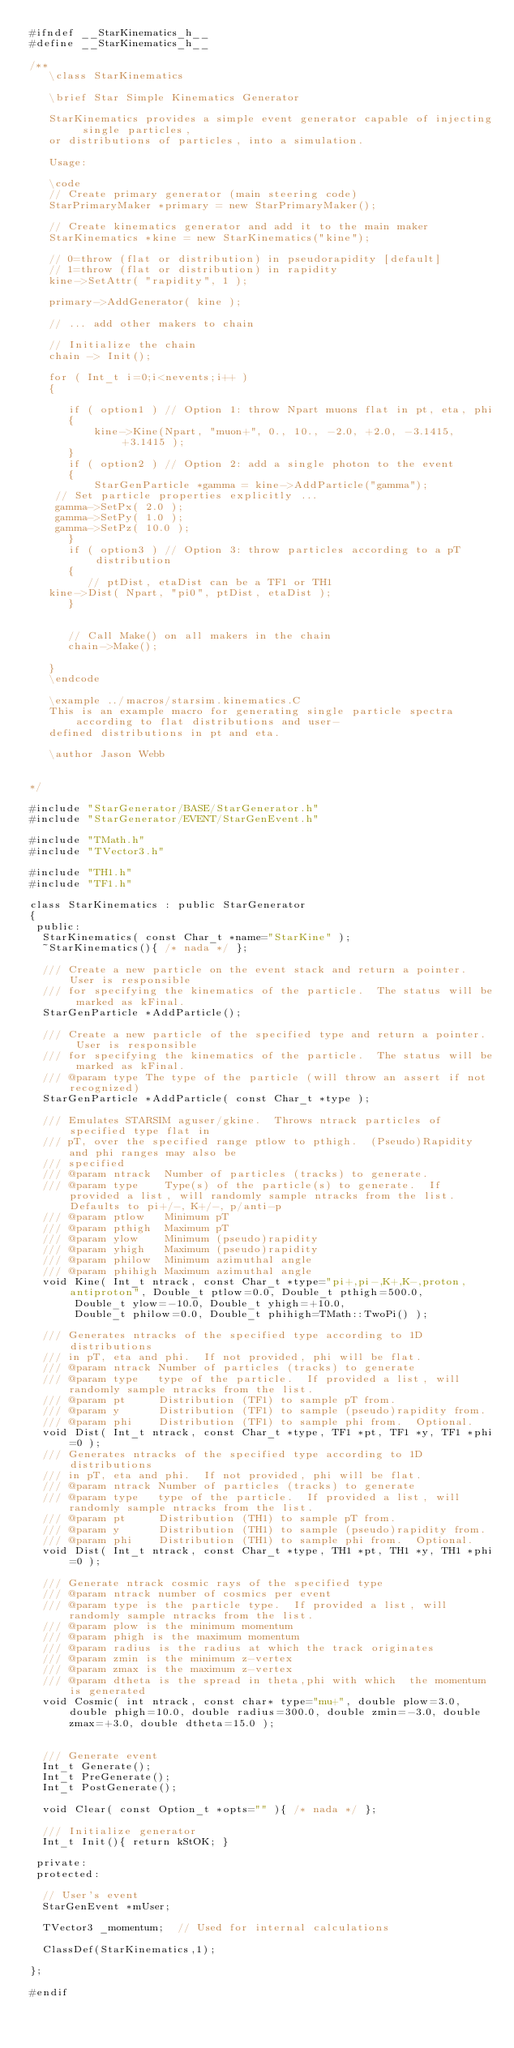Convert code to text. <code><loc_0><loc_0><loc_500><loc_500><_C_>#ifndef __StarKinematics_h__
#define __StarKinematics_h__

/**
   \class StarKinematics

   \brief Star Simple Kinematics Generator

   StarKinematics provides a simple event generator capable of injecting single particles, 
   or distributions of particles, into a simulation.

   Usage:

   \code
   // Create primary generator (main steering code)
   StarPrimaryMaker *primary = new StarPrimaryMaker();

   // Create kinematics generator and add it to the main maker
   StarKinematics *kine = new StarKinematics("kine");

   // 0=throw (flat or distribution) in pseudorapidity [default]
   // 1=throw (flat or distribution) in rapidity
   kine->SetAttr( "rapidity", 1 );

   primary->AddGenerator( kine );
   
   // ... add other makers to chain

   // Initialize the chain
   chain -> Init();

   for ( Int_t i=0;i<nevents;i++ )
   {

      if ( option1 ) // Option 1: throw Npart muons flat in pt, eta, phi
      {
          kine->Kine(Npart, "muon+", 0., 10., -2.0, +2.0, -3.1415, +3.1415 );
      }
      if ( option2 ) // Option 2: add a single photon to the event
      {
          StarGenParticle *gamma = kine->AddParticle("gamma");
	  // Set particle properties explicitly ...
	  gamma->SetPx( 2.0 );
	  gamma->SetPy( 1.0 );
	  gamma->SetPz( 10.0 ); 
      }
      if ( option3 ) // Option 3: throw particles according to a pT distribution
      {
         // ptDist, etaDist can be a TF1 or TH1
	 kine->Dist( Npart, "pi0", ptDist, etaDist );
      }


      // Call Make() on all makers in the chain
      chain->Make();

   }
   \endcode

   \example ../macros/starsim.kinematics.C
   This is an example macro for generating single particle spectra according to flat distributions and user-
   defined distributions in pt and eta.
      
   \author Jason Webb

   
*/

#include "StarGenerator/BASE/StarGenerator.h"
#include "StarGenerator/EVENT/StarGenEvent.h"

#include "TMath.h"
#include "TVector3.h"

#include "TH1.h"
#include "TF1.h"

class StarKinematics : public StarGenerator
{
 public:
  StarKinematics( const Char_t *name="StarKine" );
  ~StarKinematics(){ /* nada */ };

  /// Create a new particle on the event stack and return a pointer.  User is responsible
  /// for specifying the kinematics of the particle.  The status will be marked as kFinal.
  StarGenParticle *AddParticle();

  /// Create a new particle of the specified type and return a pointer.  User is responsible
  /// for specifying the kinematics of the particle.  The status will be marked as kFinal.
  /// @param type The type of the particle (will throw an assert if not recognized)
  StarGenParticle *AddParticle( const Char_t *type );

  /// Emulates STARSIM aguser/gkine.  Throws ntrack particles of specified type flat in
  /// pT, over the specified range ptlow to pthigh.  (Pseudo)Rapidity and phi ranges may also be
  /// specified
  /// @param ntrack  Number of particles (tracks) to generate.
  /// @param type    Type(s) of the particle(s) to generate.  If provided a list, will randomly sample ntracks from the list.  Defaults to pi+/-, K+/-, p/anti-p
  /// @param ptlow   Minimum pT
  /// @param pthigh  Maximum pT
  /// @param ylow    Minimum (pseudo)rapidity
  /// @param yhigh   Maximum (pseudo)rapidity
  /// @param philow  Minimum azimuthal angle
  /// @param phihigh Maximum azimuthal angle
  void Kine( Int_t ntrack, const Char_t *type="pi+,pi-,K+,K-,proton,antiproton", Double_t ptlow=0.0, Double_t pthigh=500.0,
	     Double_t ylow=-10.0, Double_t yhigh=+10.0,
	     Double_t philow=0.0, Double_t phihigh=TMath::TwoPi() );

  /// Generates ntracks of the specified type according to 1D distributions
  /// in pT, eta and phi.  If not provided, phi will be flat.
  /// @param ntrack Number of particles (tracks) to generate
  /// @param type   type of the particle.  If provided a list, will randomly sample ntracks from the list.
  /// @param pt     Distribution (TF1) to sample pT from.
  /// @param y      Distribution (TF1) to sample (pseudo)rapidity from.
  /// @param phi    Distribution (TF1) to sample phi from.  Optional.
  void Dist( Int_t ntrack, const Char_t *type, TF1 *pt, TF1 *y, TF1 *phi=0 );
  /// Generates ntracks of the specified type according to 1D distributions
  /// in pT, eta and phi.  If not provided, phi will be flat.
  /// @param ntrack Number of particles (tracks) to generate
  /// @param type   type of the particle.  If provided a list, will randomly sample ntracks from the list.
  /// @param pt     Distribution (TH1) to sample pT from.
  /// @param y      Distribution (TH1) to sample (pseudo)rapidity from.
  /// @param phi    Distribution (TH1) to sample phi from.  Optional.
  void Dist( Int_t ntrack, const Char_t *type, TH1 *pt, TH1 *y, TH1 *phi=0 );
  
  /// Generate ntrack cosmic rays of the specified type
  /// @param ntrack number of cosmics per event
  /// @param type is the particle type.  If provided a list, will randomly sample ntracks from the list.
  /// @param plow is the minimum momentum
  /// @param phigh is the maximum momentum
  /// @param radius is the radius at which the track originates
  /// @param zmin is the minimum z-vertex
  /// @param zmax is the maximum z-vertex
  /// @param dtheta is the spread in theta,phi with which  the momentum is generated
  void Cosmic( int ntrack, const char* type="mu+", double plow=3.0, double phigh=10.0, double radius=300.0, double zmin=-3.0, double zmax=+3.0, double dtheta=15.0 );


  /// Generate event
  Int_t Generate();
  Int_t PreGenerate();
  Int_t PostGenerate();

  void Clear( const Option_t *opts="" ){ /* nada */ };

  /// Initialize generator
  Int_t Init(){ return kStOK; }

 private:
 protected:

  // User's event
  StarGenEvent *mUser;

  TVector3 _momentum;  // Used for internal calculations

  ClassDef(StarKinematics,1);

};

#endif
</code> 